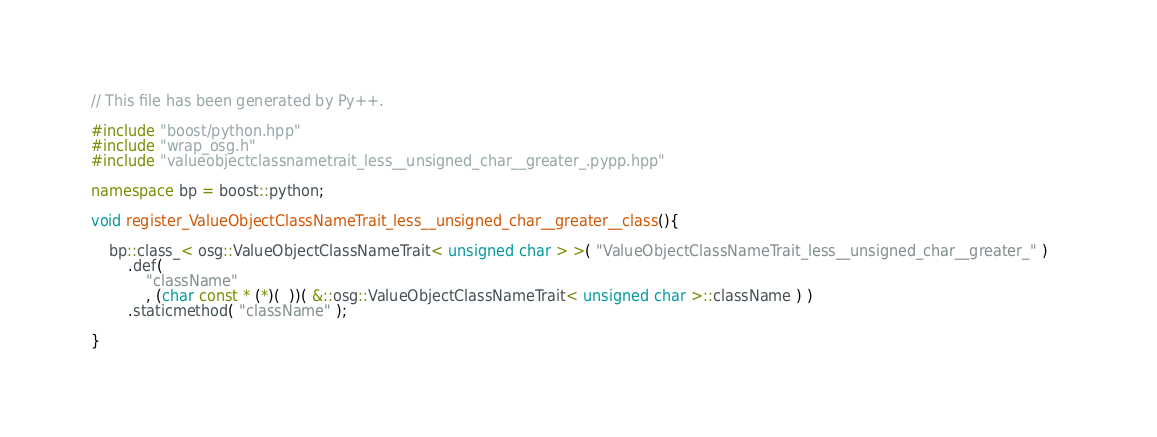<code> <loc_0><loc_0><loc_500><loc_500><_C++_>// This file has been generated by Py++.

#include "boost/python.hpp"
#include "wrap_osg.h"
#include "valueobjectclassnametrait_less__unsigned_char__greater_.pypp.hpp"

namespace bp = boost::python;

void register_ValueObjectClassNameTrait_less__unsigned_char__greater__class(){

    bp::class_< osg::ValueObjectClassNameTrait< unsigned char > >( "ValueObjectClassNameTrait_less__unsigned_char__greater_" )    
        .def( 
            "className"
            , (char const * (*)(  ))( &::osg::ValueObjectClassNameTrait< unsigned char >::className ) )    
        .staticmethod( "className" );

}
</code> 